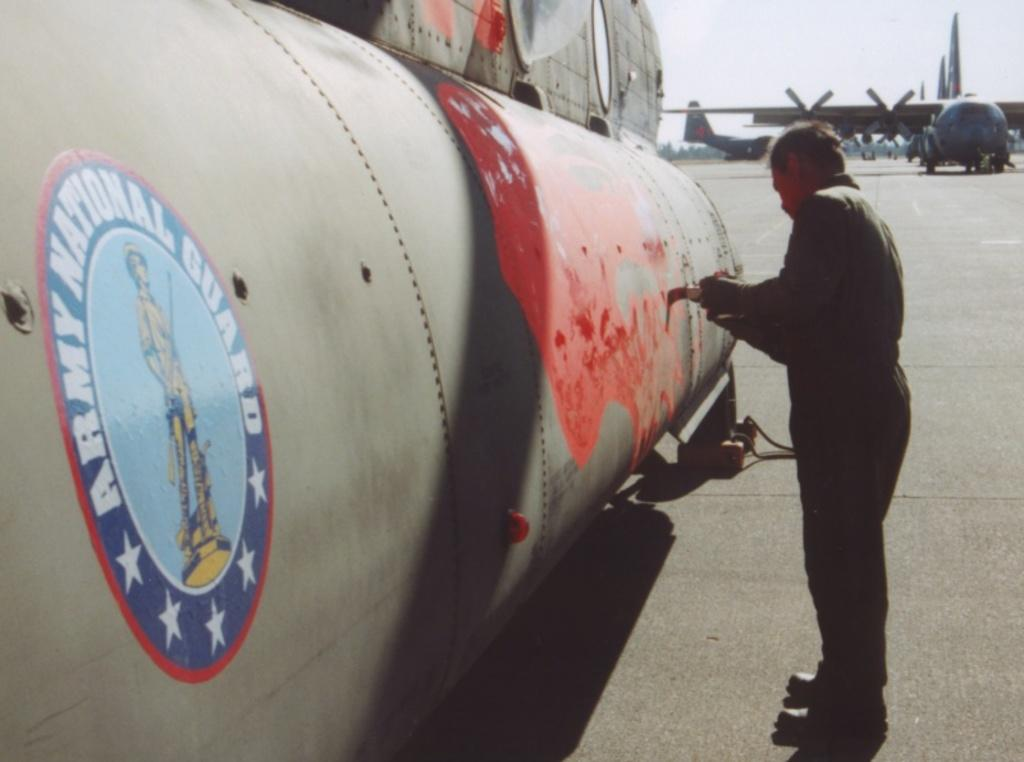<image>
Relay a brief, clear account of the picture shown. a man painting a plane that says ARMY NATIONAL GUARD on the side with a soldier picture. 